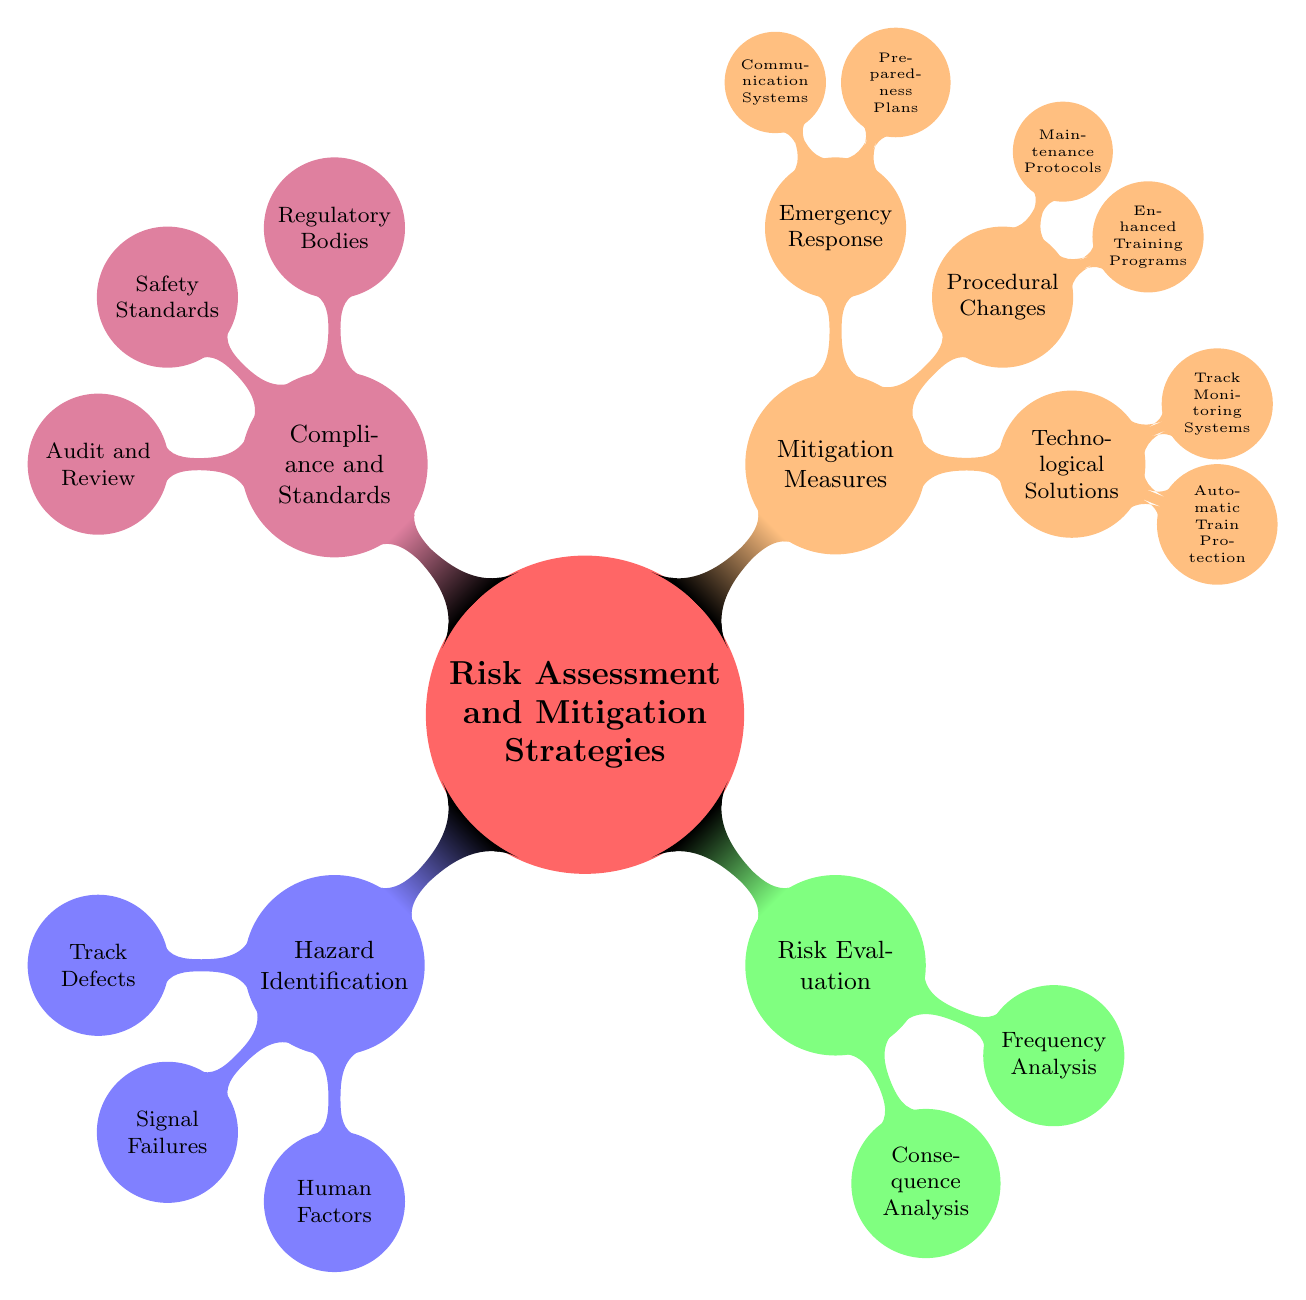What's the main topic of the mind map? The central node of the mind map is labeled "Risk Assessment and Mitigation Strategies," which serves as the main topic of the diagram.
Answer: Risk Assessment and Mitigation Strategies How many primary branches emanate from the central node? The central node branches into four main categories: Hazard Identification, Risk Evaluation, Mitigation Measures, and Compliance and Standards. Counting these branches reveals a total of four.
Answer: 4 What are the three categories under Mitigation Measures? The three categories listed under Mitigation Measures are Technological Solutions, Procedural Changes, and Emergency Response. Identifying these areas provides the answer.
Answer: Technological Solutions, Procedural Changes, Emergency Response Which node describes factors related to human involvement? The node "Human Factors" under the "Hazard Identification" category specifically addresses issues related to people, such as fatigue and human error. This leads directly to the answer.
Answer: Human Factors What types of systems are included under Technological Solutions? Within the Technological Solutions node, two types of systems are mentioned: Automatic Train Protection and Track Monitoring Systems. By referencing this section of the mind map, we derive the answer.
Answer: Automatic Train Protection, Track Monitoring Systems Which regulatory body is mentioned in the Compliance and Standards section? The "Regulatory Bodies" node features "Federal Railroad Administration" as one of the entities, indicating a focus on compliance within this framework. This allows us to answer the question.
Answer: Federal Railroad Administration What analysis is used to evaluate consequences in risk assessments? The node titled "Consequence Analysis" specifically addresses the evaluation of consequences related to potential risks. By locating this component, we can answer.
Answer: Consequence Analysis How many child nodes are under Hazard Identification and what are they? Hazard Identification has three child nodes: Track Defects, Signal Failures, and Human Factors. Counting these yields a total of three nodes, which provides a complete answer.
Answer: Track Defects, Signal Failures, Human Factors What does the Compliance and Standards section focus on? The Compliance and Standards section lists aspects related to regulatory bodies, safety standards, and audit and review processes. These elements outline its focus clearly.
Answer: Regulatory Bodies, Safety Standards, Audit and Review 